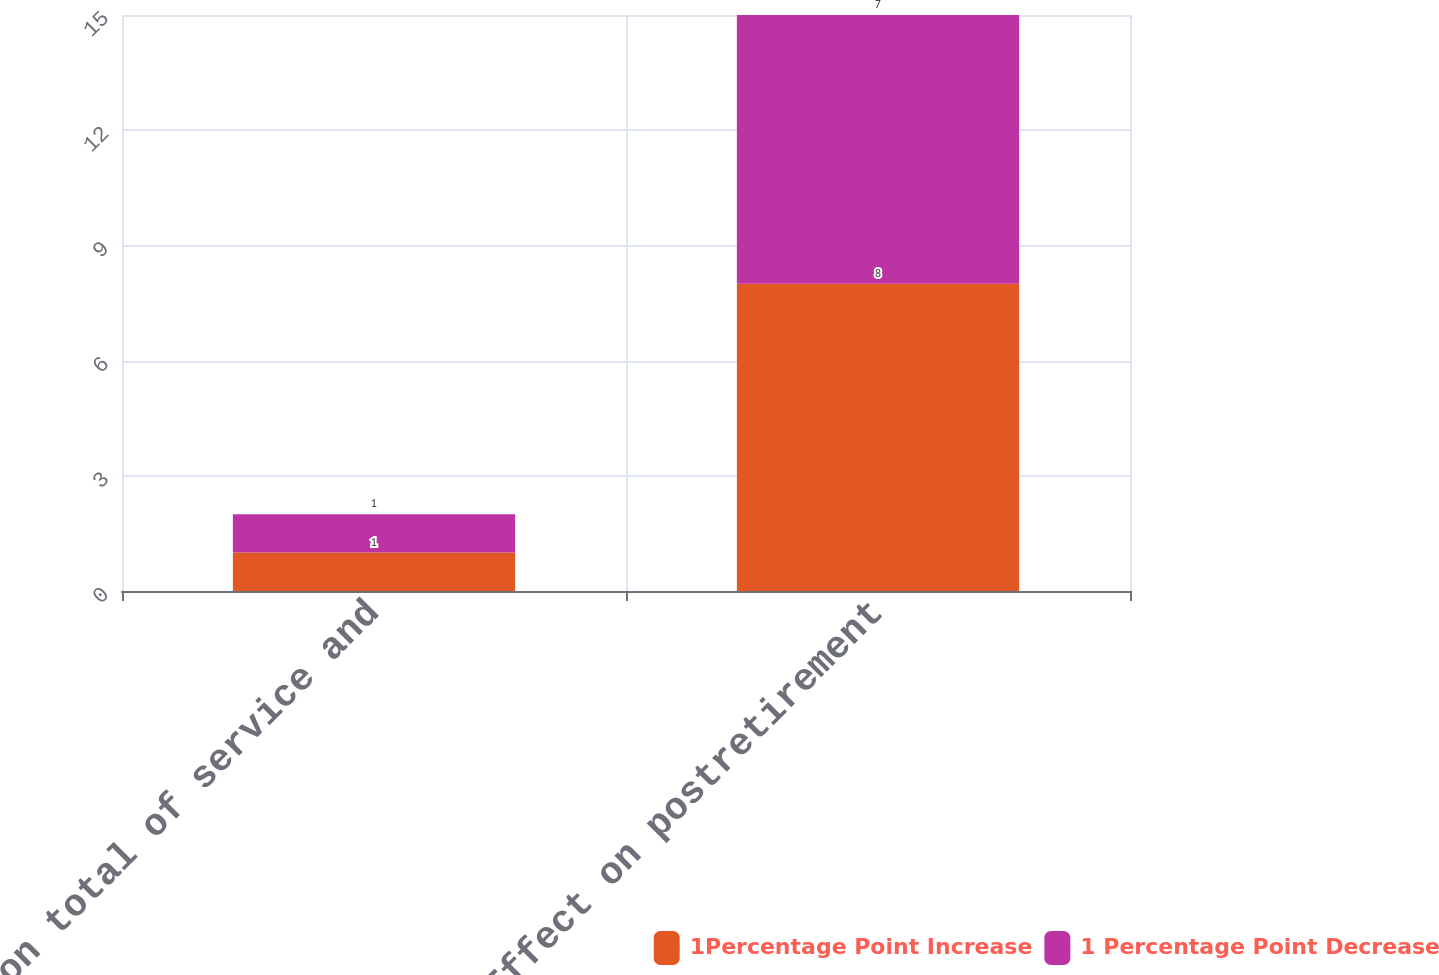Convert chart. <chart><loc_0><loc_0><loc_500><loc_500><stacked_bar_chart><ecel><fcel>Effect on total of service and<fcel>Effect on postretirement<nl><fcel>1Percentage Point Increase<fcel>1<fcel>8<nl><fcel>1 Percentage Point Decrease<fcel>1<fcel>7<nl></chart> 